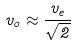<formula> <loc_0><loc_0><loc_500><loc_500>v _ { o } \approx \frac { v _ { e } } { \sqrt { 2 } }</formula> 